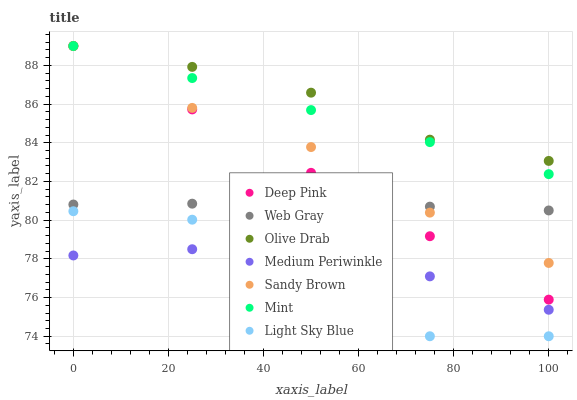Does Light Sky Blue have the minimum area under the curve?
Answer yes or no. Yes. Does Olive Drab have the maximum area under the curve?
Answer yes or no. Yes. Does Mint have the minimum area under the curve?
Answer yes or no. No. Does Mint have the maximum area under the curve?
Answer yes or no. No. Is Deep Pink the smoothest?
Answer yes or no. Yes. Is Light Sky Blue the roughest?
Answer yes or no. Yes. Is Mint the smoothest?
Answer yes or no. No. Is Mint the roughest?
Answer yes or no. No. Does Light Sky Blue have the lowest value?
Answer yes or no. Yes. Does Mint have the lowest value?
Answer yes or no. No. Does Olive Drab have the highest value?
Answer yes or no. Yes. Does Medium Periwinkle have the highest value?
Answer yes or no. No. Is Medium Periwinkle less than Deep Pink?
Answer yes or no. Yes. Is Web Gray greater than Light Sky Blue?
Answer yes or no. Yes. Does Light Sky Blue intersect Medium Periwinkle?
Answer yes or no. Yes. Is Light Sky Blue less than Medium Periwinkle?
Answer yes or no. No. Is Light Sky Blue greater than Medium Periwinkle?
Answer yes or no. No. Does Medium Periwinkle intersect Deep Pink?
Answer yes or no. No. 